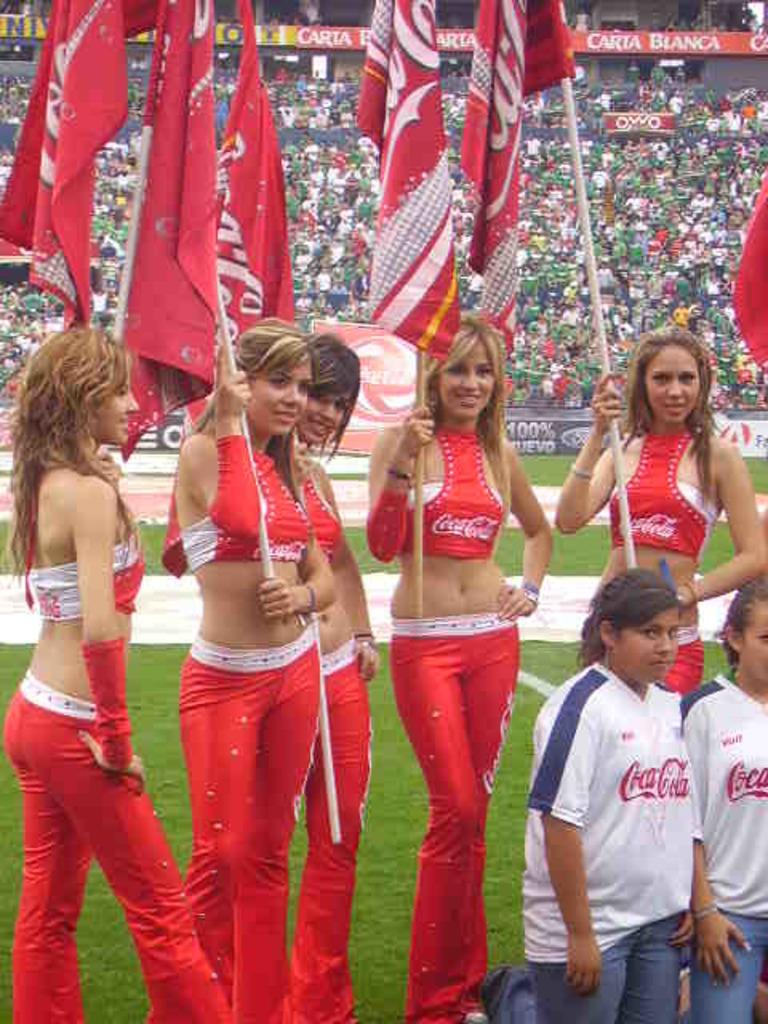<image>
Share a concise interpretation of the image provided. Both the beautiful ladies and the younger kids are wearing tops sponsored by Coca-cola. 